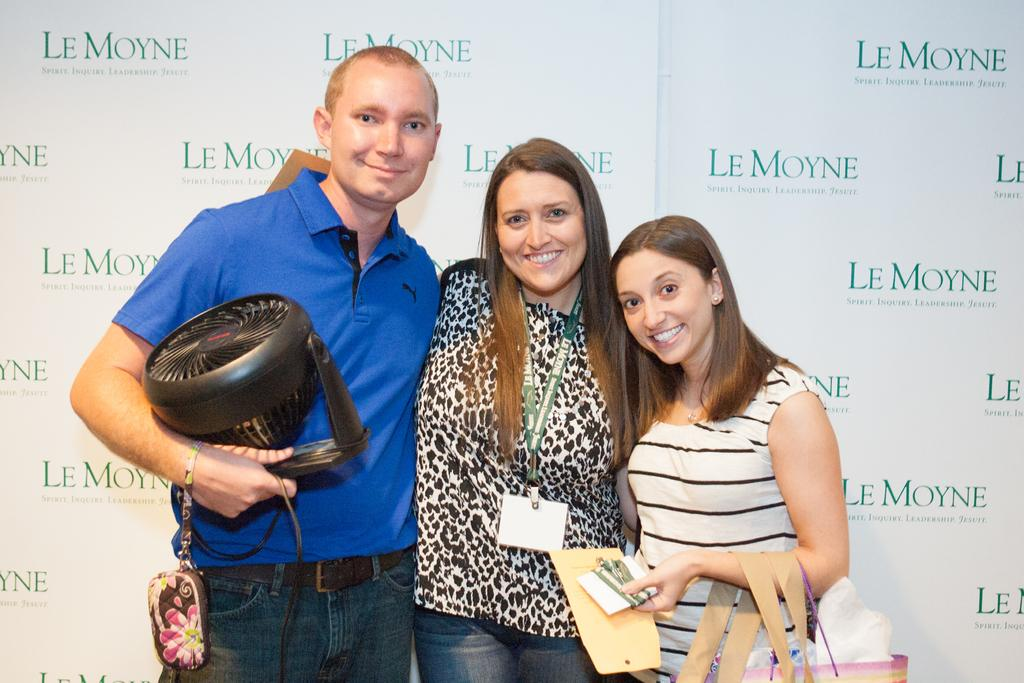How many people are present in the image? There are three people in the image. Can you describe the text on the wall in the background? Unfortunately, the specific text on the wall cannot be determined from the image. What type of bone can be seen in the image? There is no bone present in the image. What offer is being made by the people in the image? There is no offer being made by the people in the image; we cannot determine their actions or intentions from the image alone. 